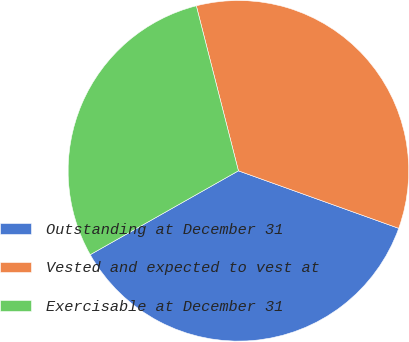Convert chart. <chart><loc_0><loc_0><loc_500><loc_500><pie_chart><fcel>Outstanding at December 31<fcel>Vested and expected to vest at<fcel>Exercisable at December 31<nl><fcel>36.32%<fcel>34.46%<fcel>29.22%<nl></chart> 